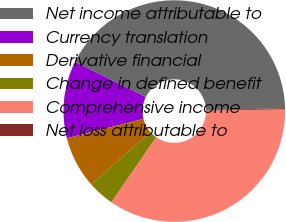<chart> <loc_0><loc_0><loc_500><loc_500><pie_chart><fcel>Net income attributable to<fcel>Currency translation<fcel>Derivative financial<fcel>Change in defined benefit<fcel>Comprehensive income<fcel>Net loss attributable to<nl><fcel>42.27%<fcel>11.27%<fcel>7.57%<fcel>3.87%<fcel>34.87%<fcel>0.17%<nl></chart> 